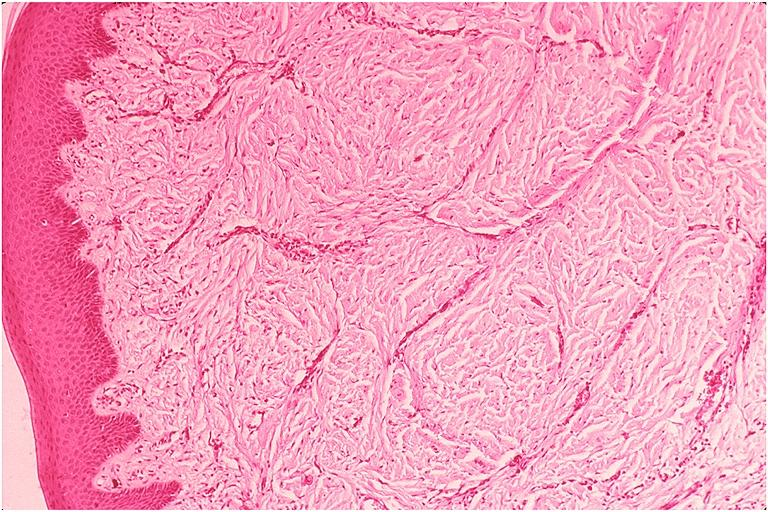does myoma lesion show epulis fissuratum?
Answer the question using a single word or phrase. No 